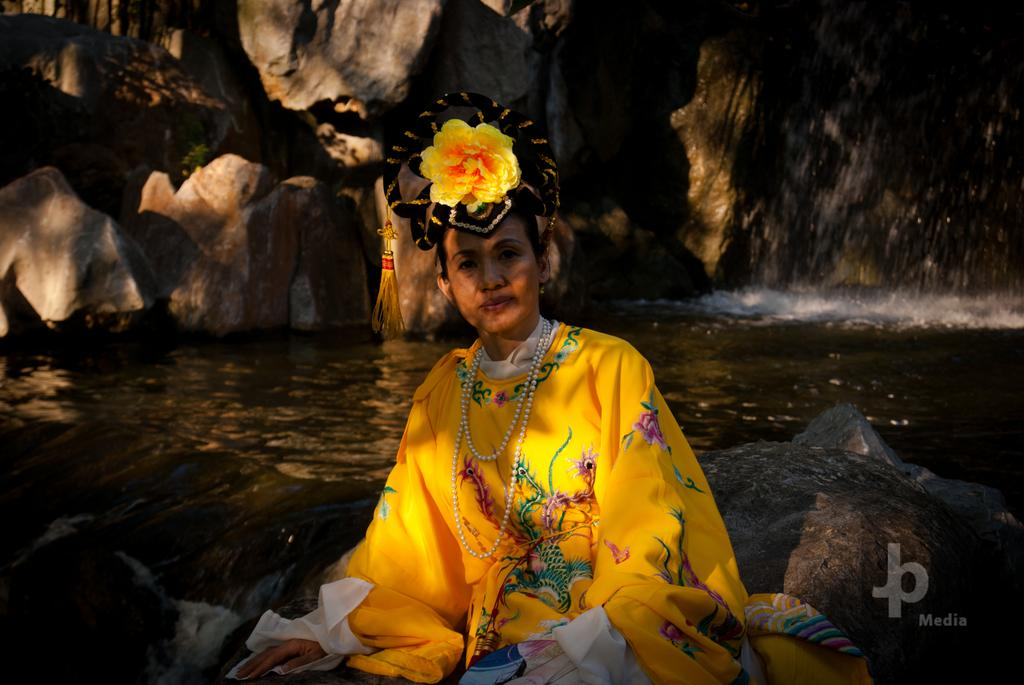What is the woman doing in the image? The woman is sitting on a rock in the image. What can be seen in the foreground of the image? There is water visible in the image. What is visible in the background of the image? There is a mountain in the background of the image. How many clovers can be found in the image? There are no clovers present in the image. What is the woman's state of mind in the image? The image does not provide information about the woman's state of mind. 